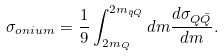<formula> <loc_0><loc_0><loc_500><loc_500>\sigma _ { o n i u m } = \frac { 1 } { 9 } \int _ { 2 m _ { Q } } ^ { 2 m _ { \bar { q } Q } } d m \frac { d \sigma _ { Q \bar { Q } } } { d m } .</formula> 